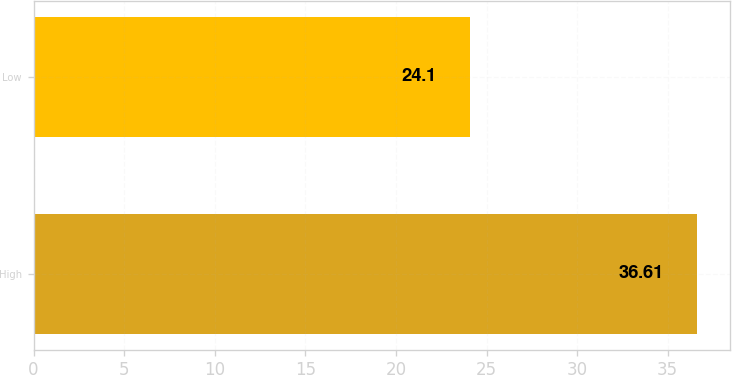Convert chart to OTSL. <chart><loc_0><loc_0><loc_500><loc_500><bar_chart><fcel>High<fcel>Low<nl><fcel>36.61<fcel>24.1<nl></chart> 